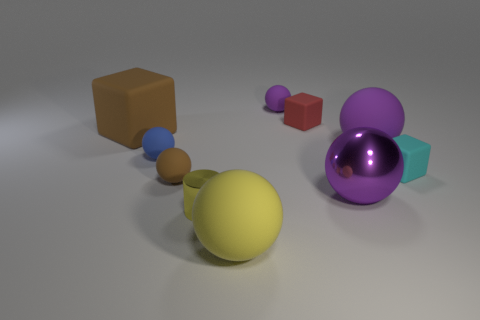Subtract all purple spheres. How many were subtracted if there are1purple spheres left? 2 Subtract all gray cubes. How many purple balls are left? 3 Subtract all purple matte spheres. How many spheres are left? 4 Subtract all brown balls. How many balls are left? 5 Subtract all cyan spheres. Subtract all green cylinders. How many spheres are left? 6 Subtract all blocks. How many objects are left? 7 Subtract all tiny red matte objects. Subtract all gray rubber cylinders. How many objects are left? 9 Add 3 small objects. How many small objects are left? 9 Add 3 green objects. How many green objects exist? 3 Subtract 0 blue cylinders. How many objects are left? 10 